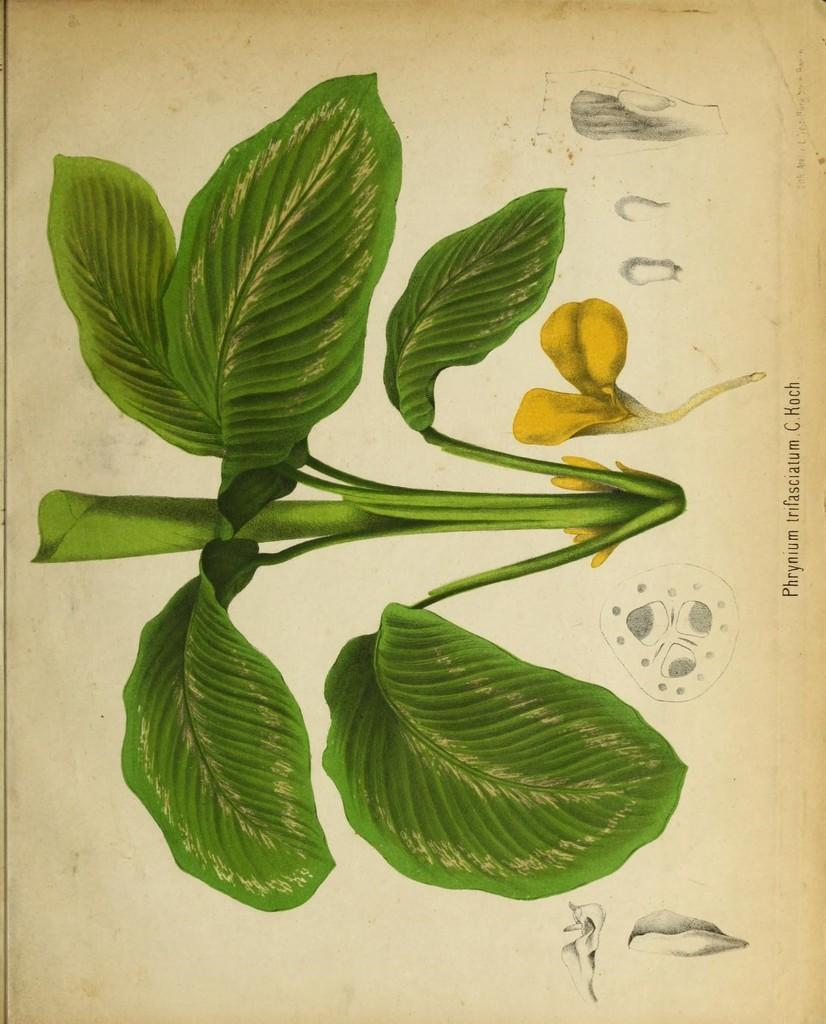What is written on the paper in the image? The facts do not specify the content of the text on the paper. What type of plant is in the image? The facts do not specify the type of plant in the image. What can be seen in addition to the plant in the image? There are flowers in the image. How many cherries are on the plant in the image? There are no cherries present in the image. Can you describe the route the flowers take in the image? The flowers are stationary in the image and do not follow a route. 